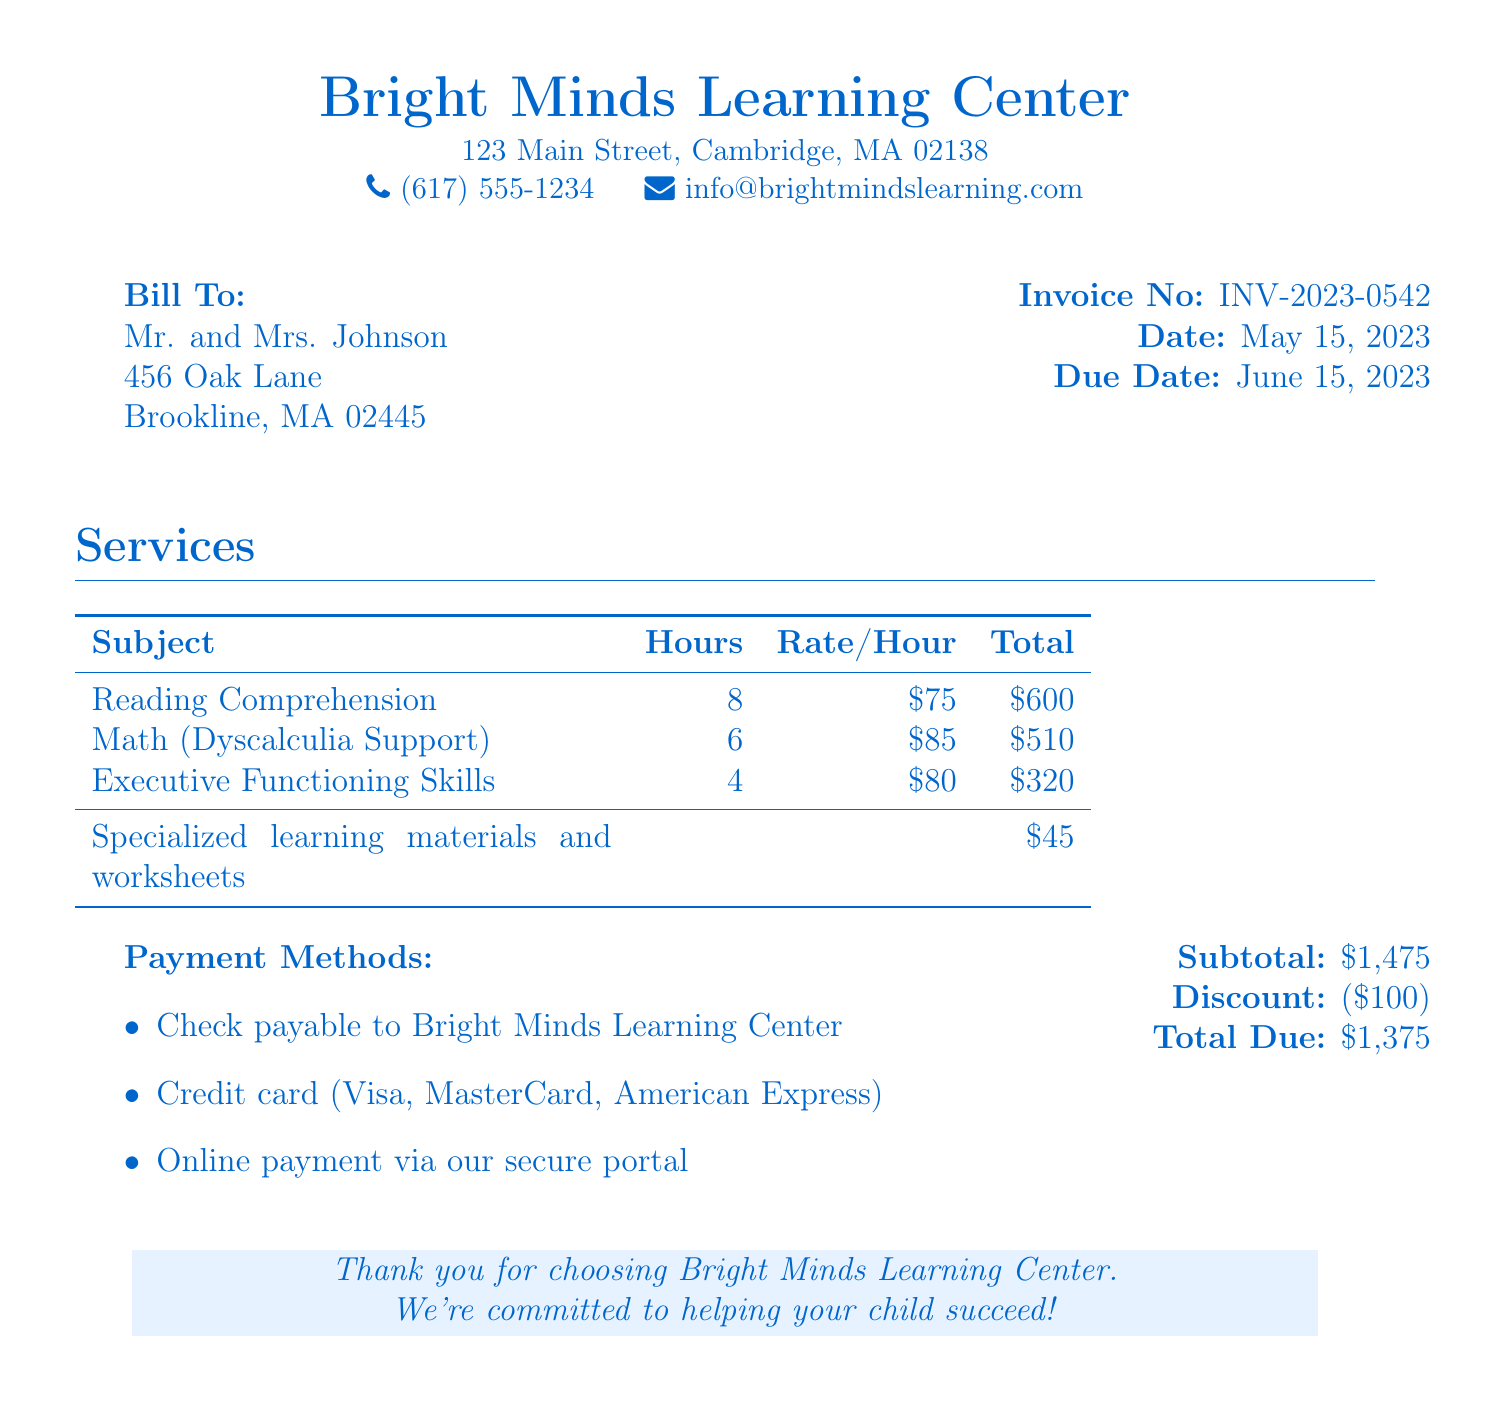What is the name of the tutoring center? The name of the tutoring center is located at the top of the invoice.
Answer: Bright Minds Learning Center What is the invoice number? The invoice number is a unique identifier for the bill.
Answer: INV-2023-0542 How much is charged per hour for Math support? This is a specific rate mentioned in the services section of the document.
Answer: 85 dollars What is the total cost for Reading Comprehension tutoring? The total cost is calculated by multiplying the hours by the rate for each subject listed.
Answer: 600 dollars What is the total amount due after the discount? The document specifies the total amount due after deducting any discounts from the subtotal.
Answer: 1375 dollars How many hours of Executive Functioning Skills tutoring were provided? This is specified in the services section under the Executive Functioning Skills entry.
Answer: 4 hours What is included in the subtotal of the bill? The subtotal is the sum of all listed tutoring services and additional materials without any discounts applied.
Answer: 1475 dollars When is the payment due? This is specified in the invoice details.
Answer: June 15, 2023 What payment methods are accepted? The document outlines various payment options available for settling the invoice.
Answer: Check, Credit card, Online payment 